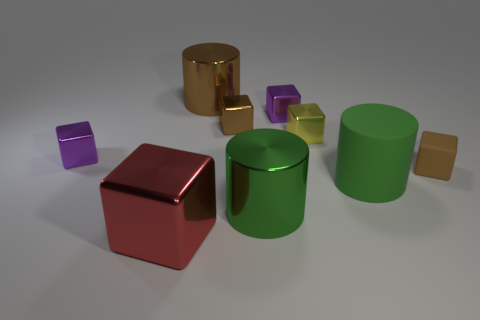Subtract all red metal blocks. How many blocks are left? 5 Subtract 1 blocks. How many blocks are left? 5 Subtract all yellow blocks. How many blocks are left? 5 Subtract all cyan blocks. Subtract all brown cylinders. How many blocks are left? 6 Add 1 large gray matte things. How many objects exist? 10 Subtract all blocks. How many objects are left? 3 Add 3 red rubber objects. How many red rubber objects exist? 3 Subtract 1 purple cubes. How many objects are left? 8 Subtract all small purple metal cubes. Subtract all rubber cylinders. How many objects are left? 6 Add 6 green objects. How many green objects are left? 8 